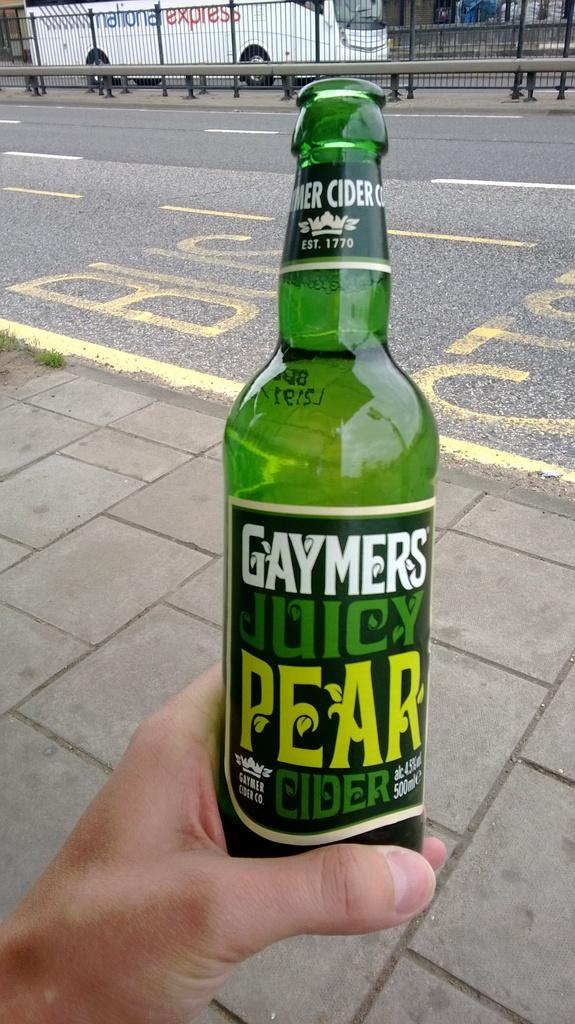What is the person holding in his left hand in the image? The person is holding a green bottle in his left hand. What can be seen in the background of the image? There is a white bus in the background of the image. What type of needle is the person using to sew the roof in the image? There is no needle or roof present in the image; it only features a person holding a green bottle and a white bus in the background. 